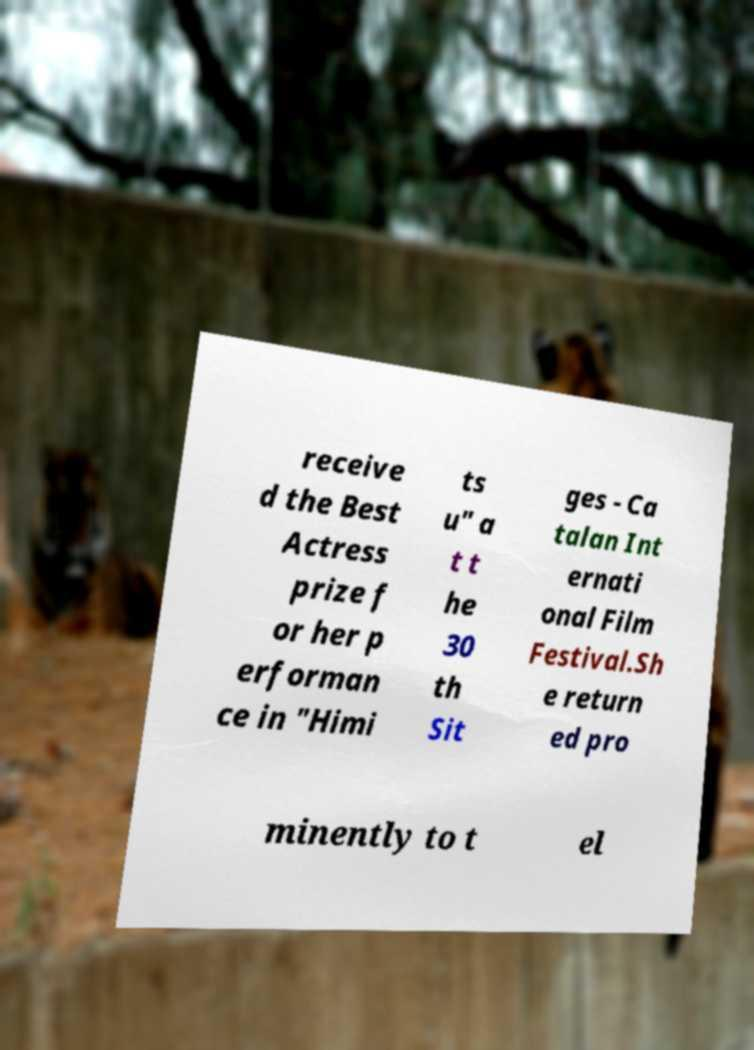There's text embedded in this image that I need extracted. Can you transcribe it verbatim? receive d the Best Actress prize f or her p erforman ce in "Himi ts u" a t t he 30 th Sit ges - Ca talan Int ernati onal Film Festival.Sh e return ed pro minently to t el 